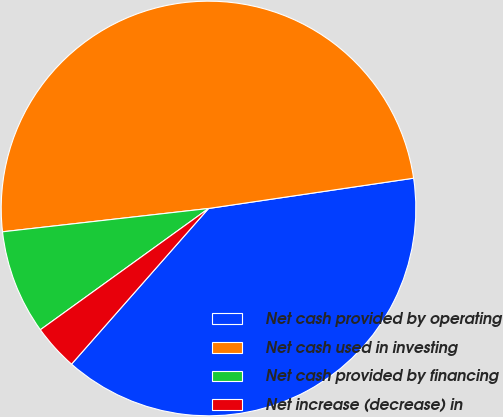Convert chart to OTSL. <chart><loc_0><loc_0><loc_500><loc_500><pie_chart><fcel>Net cash provided by operating<fcel>Net cash used in investing<fcel>Net cash provided by financing<fcel>Net increase (decrease) in<nl><fcel>38.82%<fcel>49.46%<fcel>8.15%<fcel>3.57%<nl></chart> 